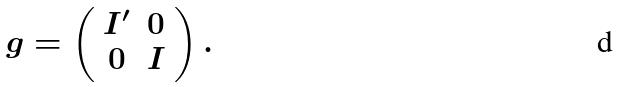<formula> <loc_0><loc_0><loc_500><loc_500>g = \left ( \begin{array} { c c } I ^ { \prime } & 0 \\ 0 & I \end{array} \right ) .</formula> 